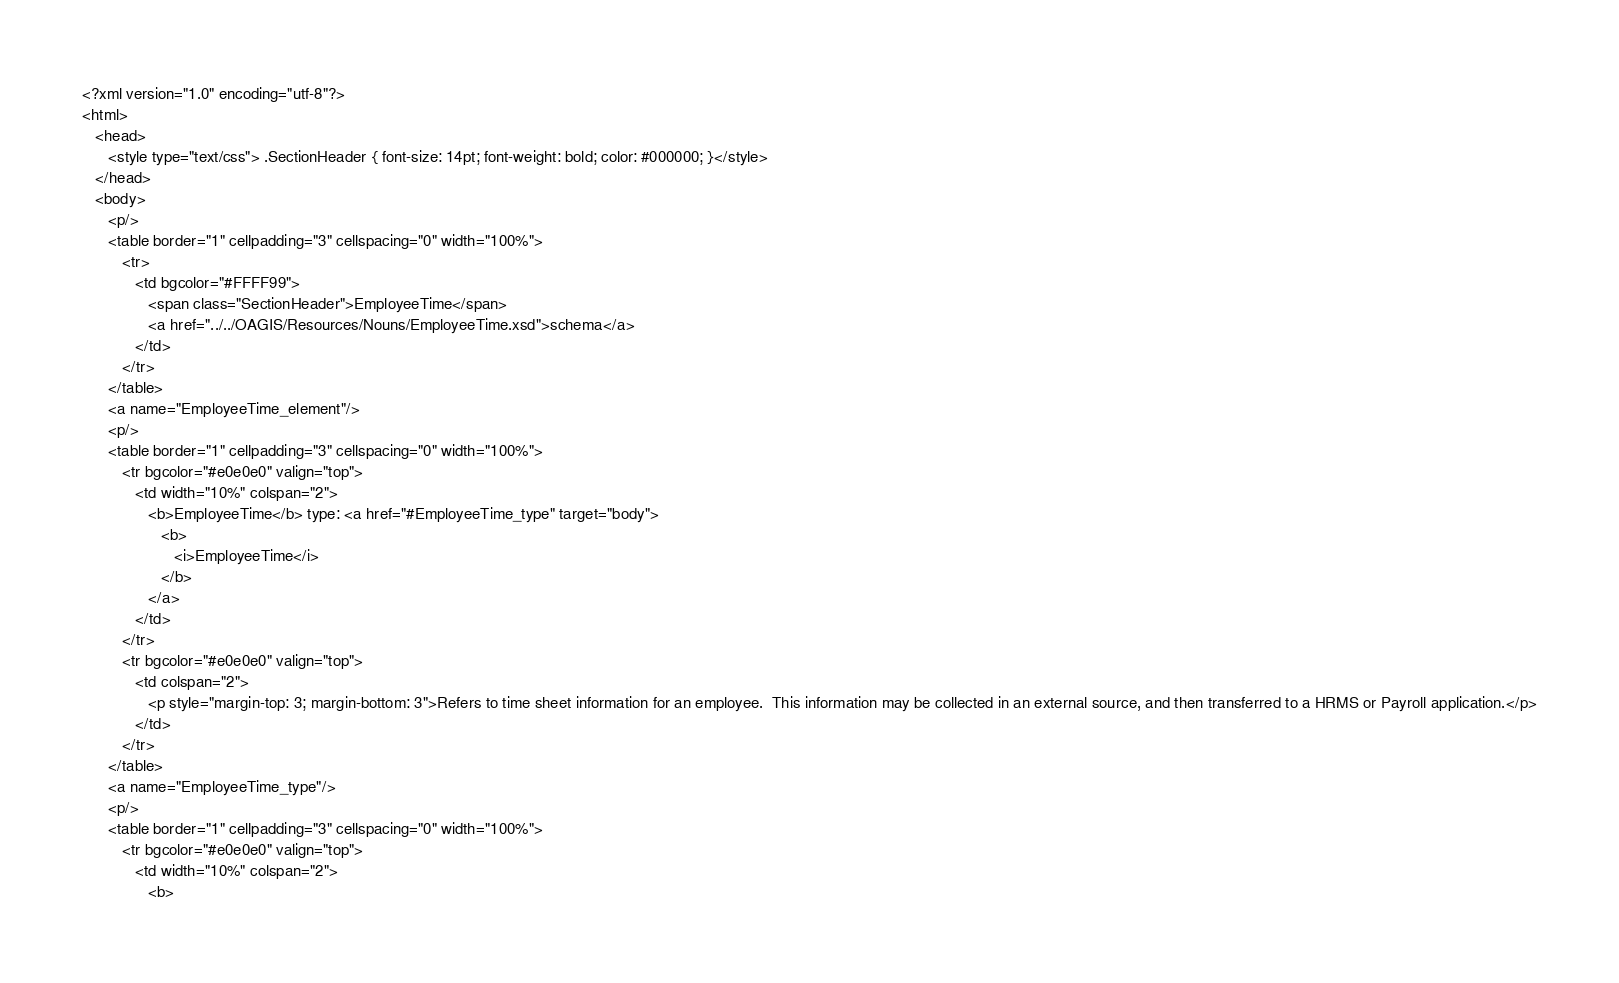<code> <loc_0><loc_0><loc_500><loc_500><_HTML_><?xml version="1.0" encoding="utf-8"?>
<html>
   <head>
      <style type="text/css"> .SectionHeader { font-size: 14pt; font-weight: bold; color: #000000; }</style>
   </head>
   <body>
      <p/>
      <table border="1" cellpadding="3" cellspacing="0" width="100%">
         <tr>
            <td bgcolor="#FFFF99">
               <span class="SectionHeader">EmployeeTime</span>
               <a href="../../OAGIS/Resources/Nouns/EmployeeTime.xsd">schema</a>
            </td>
         </tr>
      </table>
      <a name="EmployeeTime_element"/>
      <p/>
      <table border="1" cellpadding="3" cellspacing="0" width="100%">
         <tr bgcolor="#e0e0e0" valign="top">
            <td width="10%" colspan="2">
               <b>EmployeeTime</b> type: <a href="#EmployeeTime_type" target="body">
                  <b>
                     <i>EmployeeTime</i>
                  </b>
               </a>
            </td>
         </tr>
         <tr bgcolor="#e0e0e0" valign="top">
            <td colspan="2">
               <p style="margin-top: 3; margin-bottom: 3">Refers to time sheet information for an employee.  This information may be collected in an external source, and then transferred to a HRMS or Payroll application.</p>
            </td>
         </tr>
      </table>
      <a name="EmployeeTime_type"/>
      <p/>
      <table border="1" cellpadding="3" cellspacing="0" width="100%">
         <tr bgcolor="#e0e0e0" valign="top">
            <td width="10%" colspan="2">
               <b></code> 